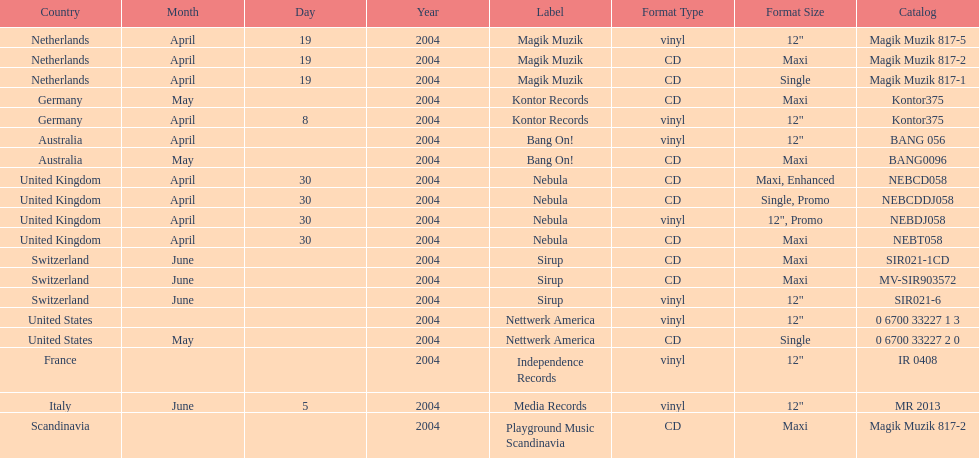Can you parse all the data within this table? {'header': ['Country', 'Month', 'Day', 'Year', 'Label', 'Format Type', 'Format Size', 'Catalog'], 'rows': [['Netherlands', 'April', '19', '2004', 'Magik Muzik', 'vinyl', '12"', 'Magik Muzik 817-5'], ['Netherlands', 'April', '19', '2004', 'Magik Muzik', 'CD', 'Maxi', 'Magik Muzik 817-2'], ['Netherlands', 'April', '19', '2004', 'Magik Muzik', 'CD', 'Single', 'Magik Muzik 817-1'], ['Germany', 'May', '', '2004', 'Kontor Records', 'CD', 'Maxi', 'Kontor375'], ['Germany', 'April', '8', '2004', 'Kontor Records', 'vinyl', '12"', 'Kontor375'], ['Australia', 'April', '', '2004', 'Bang On!', 'vinyl', '12"', 'BANG 056'], ['Australia', 'May', '', '2004', 'Bang On!', 'CD', 'Maxi', 'BANG0096'], ['United Kingdom', 'April', '30', '2004', 'Nebula', 'CD', 'Maxi, Enhanced', 'NEBCD058'], ['United Kingdom', 'April', '30', '2004', 'Nebula', 'CD', 'Single, Promo', 'NEBCDDJ058'], ['United Kingdom', 'April', '30', '2004', 'Nebula', 'vinyl', '12", Promo', 'NEBDJ058'], ['United Kingdom', 'April', '30', '2004', 'Nebula', 'CD', 'Maxi', 'NEBT058'], ['Switzerland', 'June', '', '2004', 'Sirup', 'CD', 'Maxi', 'SIR021-1CD'], ['Switzerland', 'June', '', '2004', 'Sirup', 'CD', 'Maxi', 'MV-SIR903572'], ['Switzerland', 'June', '', '2004', 'Sirup', 'vinyl', '12"', 'SIR021-6'], ['United States', '', '', '2004', 'Nettwerk America', 'vinyl', '12"', '0 6700 33227 1 3'], ['United States', 'May', '', '2004', 'Nettwerk America', 'CD', 'Single', '0 6700 33227 2 0'], ['France', '', '', '2004', 'Independence Records', 'vinyl', '12"', 'IR 0408'], ['Italy', 'June', '5', '2004', 'Media Records', 'vinyl', '12"', 'MR 2013'], ['Scandinavia', '', '', '2004', 'Playground Music Scandinavia', 'CD', 'Maxi', 'Magik Muzik 817-2']]} What region is above australia? Germany. 